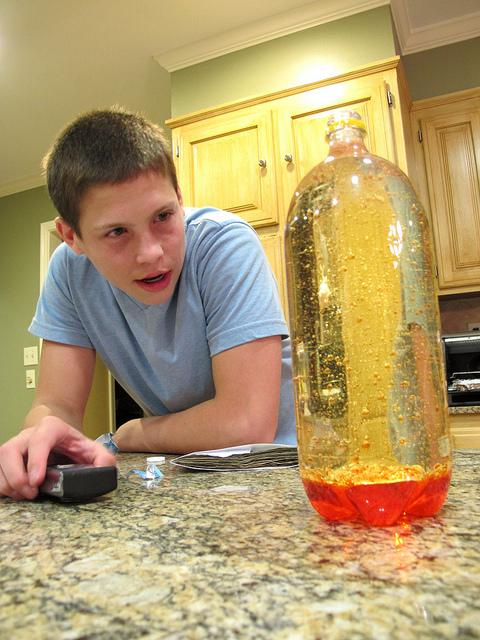What has the boy made using the bottle? lava lamp 